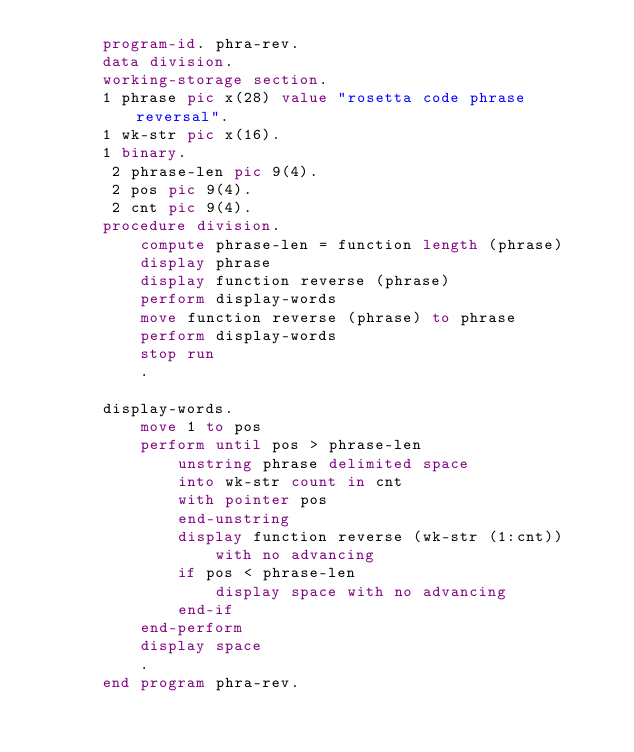<code> <loc_0><loc_0><loc_500><loc_500><_COBOL_>       program-id. phra-rev.
       data division.
       working-storage section.
       1 phrase pic x(28) value "rosetta code phrase reversal".
       1 wk-str pic x(16).
       1 binary.
        2 phrase-len pic 9(4).
        2 pos pic 9(4).
        2 cnt pic 9(4).
       procedure division.
           compute phrase-len = function length (phrase)
           display phrase
           display function reverse (phrase)
           perform display-words
           move function reverse (phrase) to phrase
           perform display-words
           stop run
           .

       display-words.
           move 1 to pos
           perform until pos > phrase-len
               unstring phrase delimited space
               into wk-str count in cnt
               with pointer pos
               end-unstring
               display function reverse (wk-str (1:cnt))
                   with no advancing
               if pos < phrase-len
                   display space with no advancing
               end-if
           end-perform
           display space
           .
       end program phra-rev.
</code> 